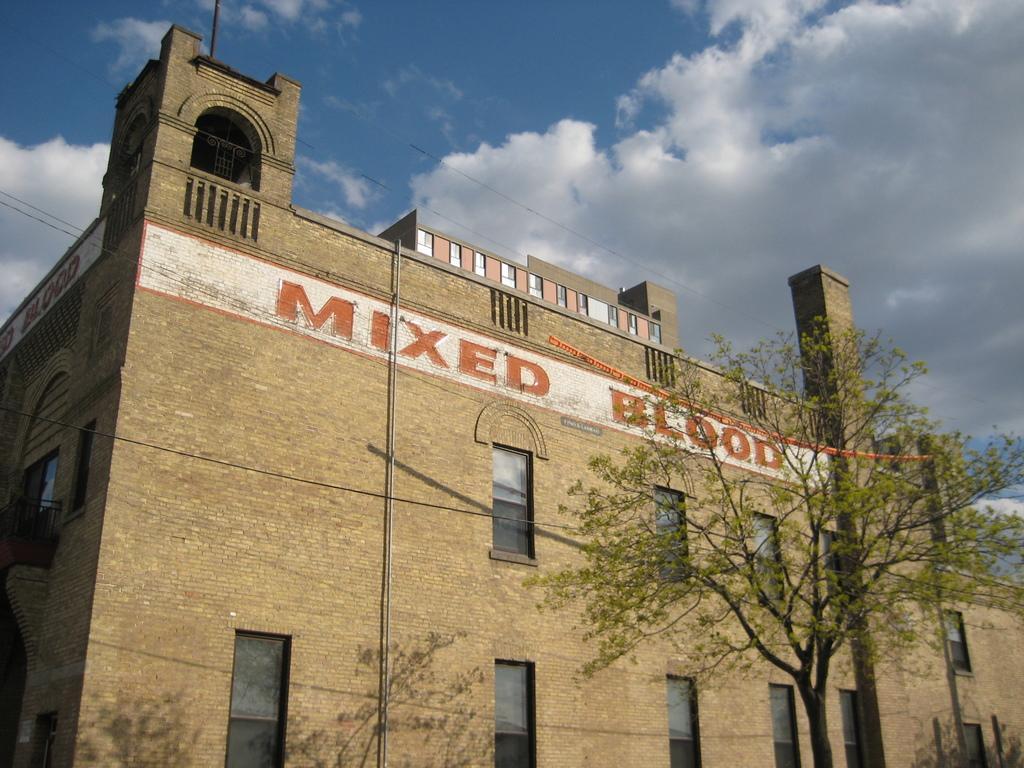Can you describe this image briefly? In this picture there is a brown color brick building with some glass windows. On the top there is a mixed blood is written with arch and balcony. Above we can see the sky and clouds. 